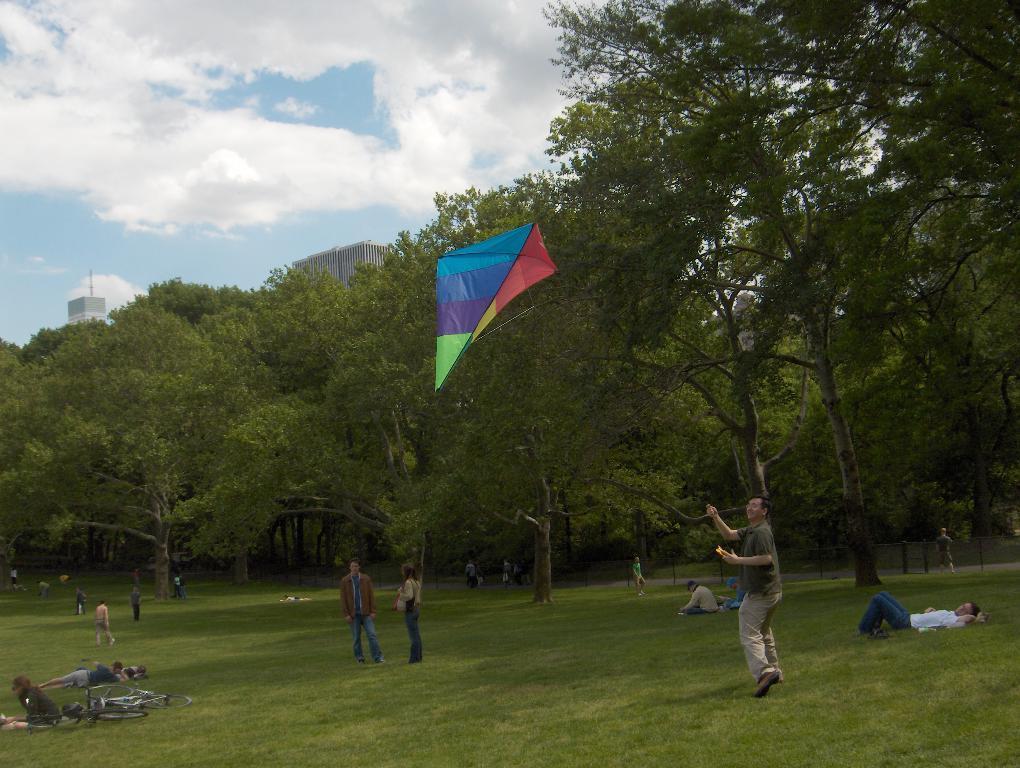Please provide a concise description of this image. In this image there are some persons standing in the middle of this image and there are some persons lying on the grassy land in the bottom of this image. There are some trees in the background. There are some buildings on the left side of this image. There is a cloudy sky on the top of this image. 